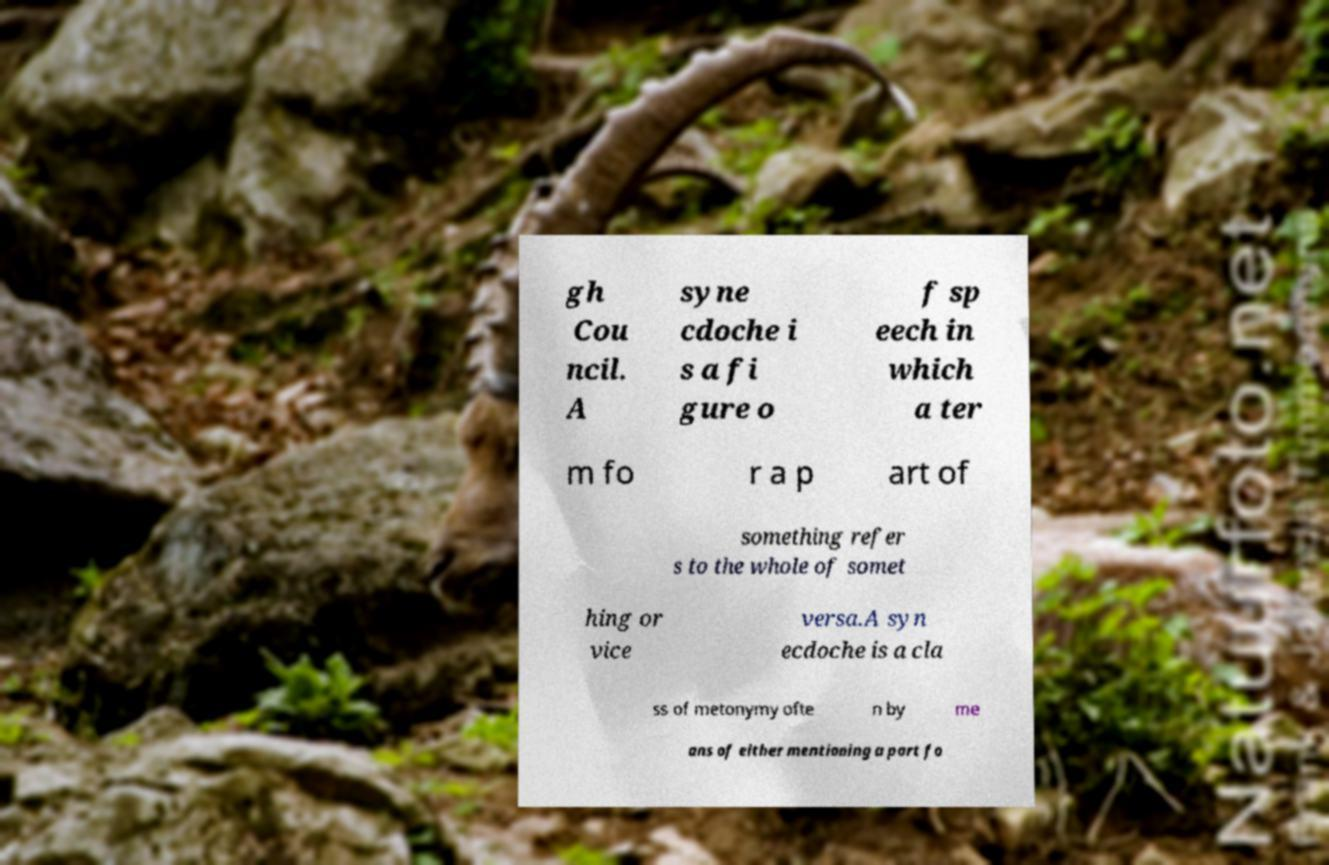For documentation purposes, I need the text within this image transcribed. Could you provide that? gh Cou ncil. A syne cdoche i s a fi gure o f sp eech in which a ter m fo r a p art of something refer s to the whole of somet hing or vice versa.A syn ecdoche is a cla ss of metonymy ofte n by me ans of either mentioning a part fo 